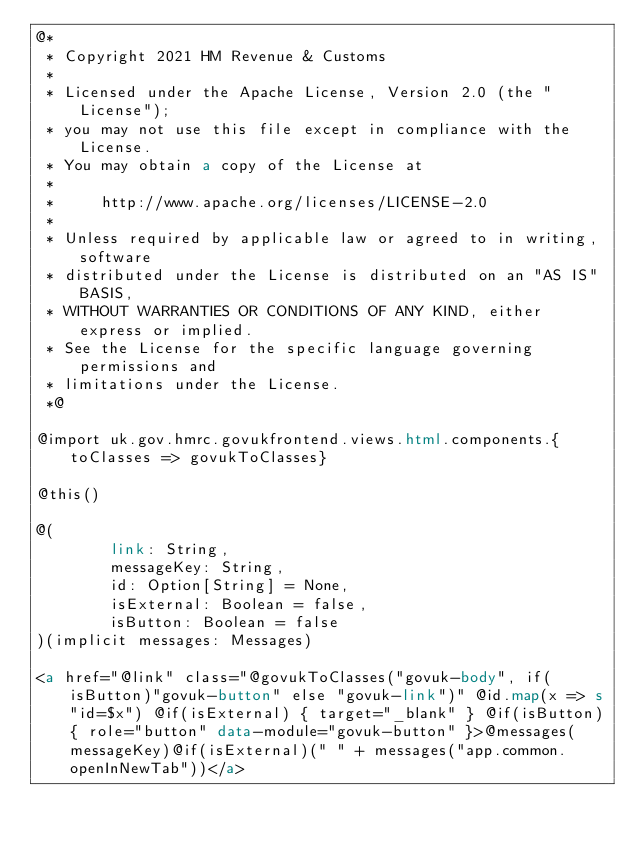Convert code to text. <code><loc_0><loc_0><loc_500><loc_500><_HTML_>@*
 * Copyright 2021 HM Revenue & Customs
 *
 * Licensed under the Apache License, Version 2.0 (the "License");
 * you may not use this file except in compliance with the License.
 * You may obtain a copy of the License at
 *
 *     http://www.apache.org/licenses/LICENSE-2.0
 *
 * Unless required by applicable law or agreed to in writing, software
 * distributed under the License is distributed on an "AS IS" BASIS,
 * WITHOUT WARRANTIES OR CONDITIONS OF ANY KIND, either express or implied.
 * See the License for the specific language governing permissions and
 * limitations under the License.
 *@

@import uk.gov.hmrc.govukfrontend.views.html.components.{toClasses => govukToClasses}

@this()

@(
        link: String,
        messageKey: String,
        id: Option[String] = None,
        isExternal: Boolean = false,
        isButton: Boolean = false
)(implicit messages: Messages)

<a href="@link" class="@govukToClasses("govuk-body", if(isButton)"govuk-button" else "govuk-link")" @id.map(x => s"id=$x") @if(isExternal) { target="_blank" } @if(isButton){ role="button" data-module="govuk-button" }>@messages(messageKey)@if(isExternal)(" " + messages("app.common.openInNewTab"))</a></code> 